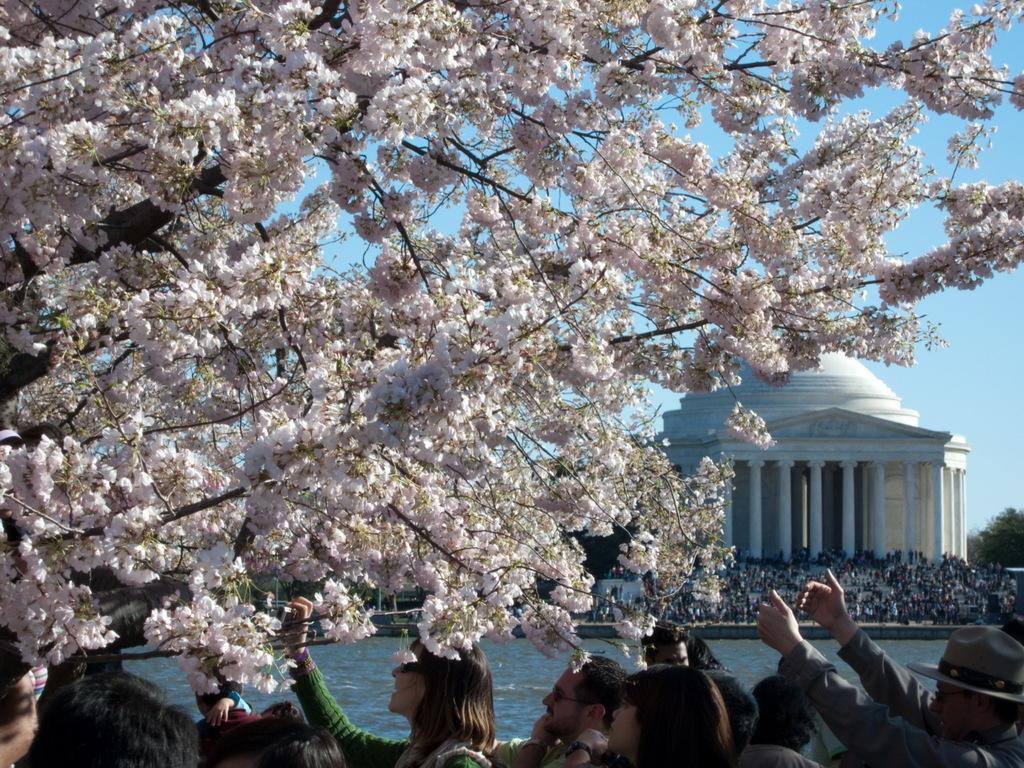What type of flowers can be seen in the image? There are cherry blossoms in the image. What are the people in the image doing? There are persons standing on the ground in the image. What can be seen in the background of the image? There is water, a building, and pillars visible in the image. What is visible in the sky in the image? The sky is visible in the image. How many mice can be seen in the image? There are no mice present in the image. What type of stew is being served in the image? There is no stew present in the image. 